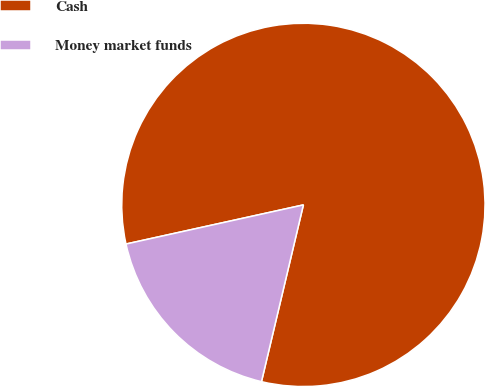Convert chart. <chart><loc_0><loc_0><loc_500><loc_500><pie_chart><fcel>Cash<fcel>Money market funds<nl><fcel>82.16%<fcel>17.84%<nl></chart> 